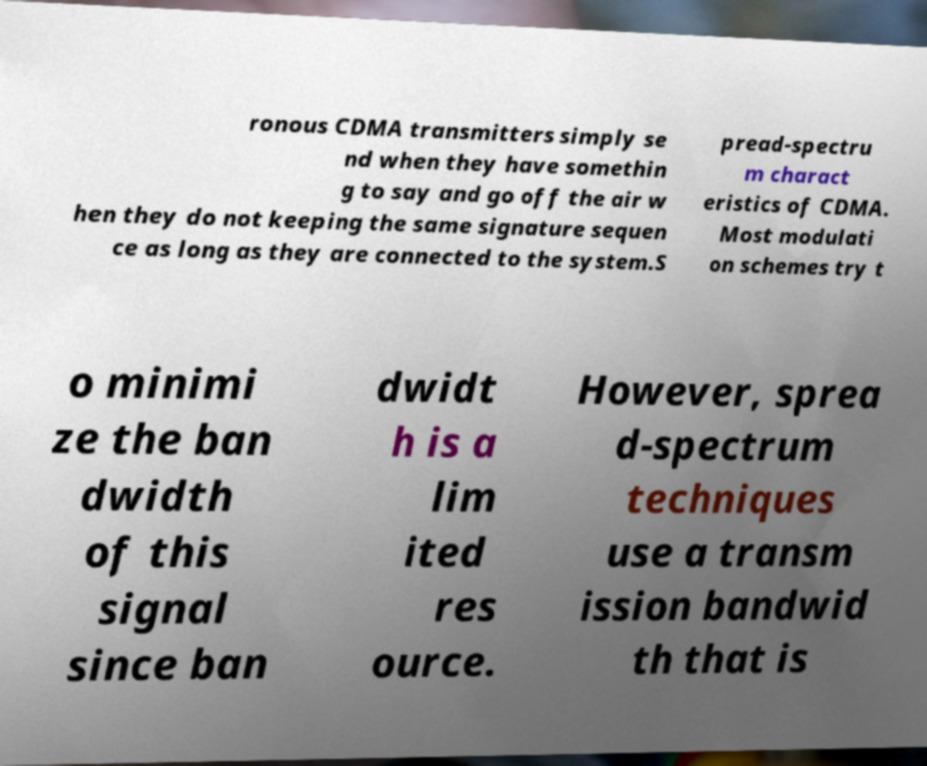Could you assist in decoding the text presented in this image and type it out clearly? ronous CDMA transmitters simply se nd when they have somethin g to say and go off the air w hen they do not keeping the same signature sequen ce as long as they are connected to the system.S pread-spectru m charact eristics of CDMA. Most modulati on schemes try t o minimi ze the ban dwidth of this signal since ban dwidt h is a lim ited res ource. However, sprea d-spectrum techniques use a transm ission bandwid th that is 